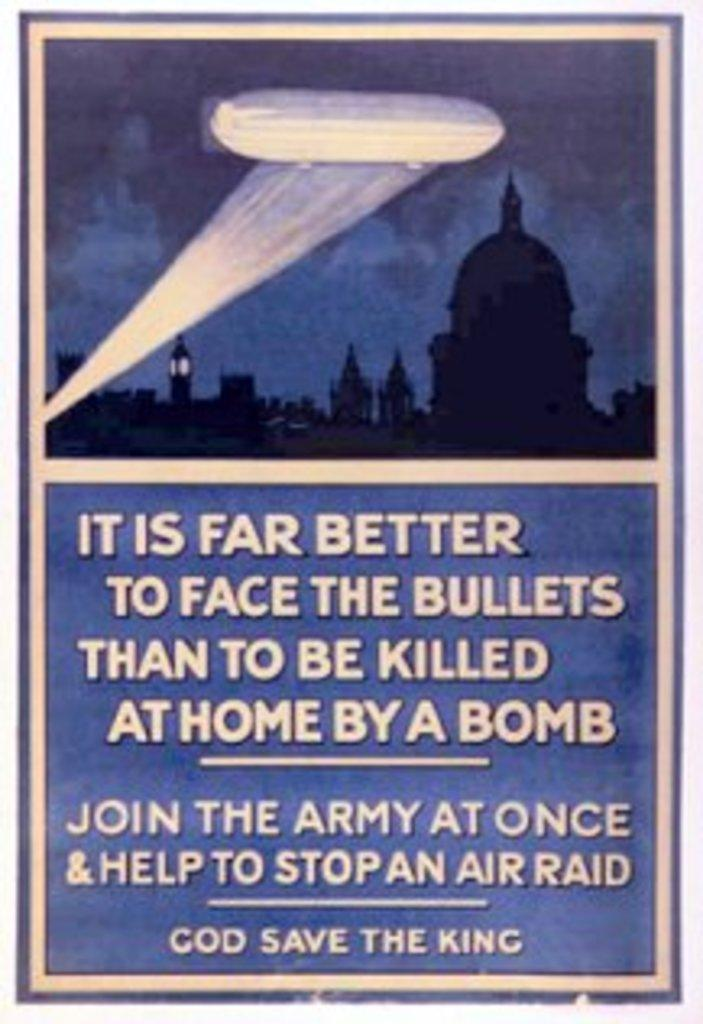<image>
Relay a brief, clear account of the picture shown. The poster is asking people to join the army at once. 